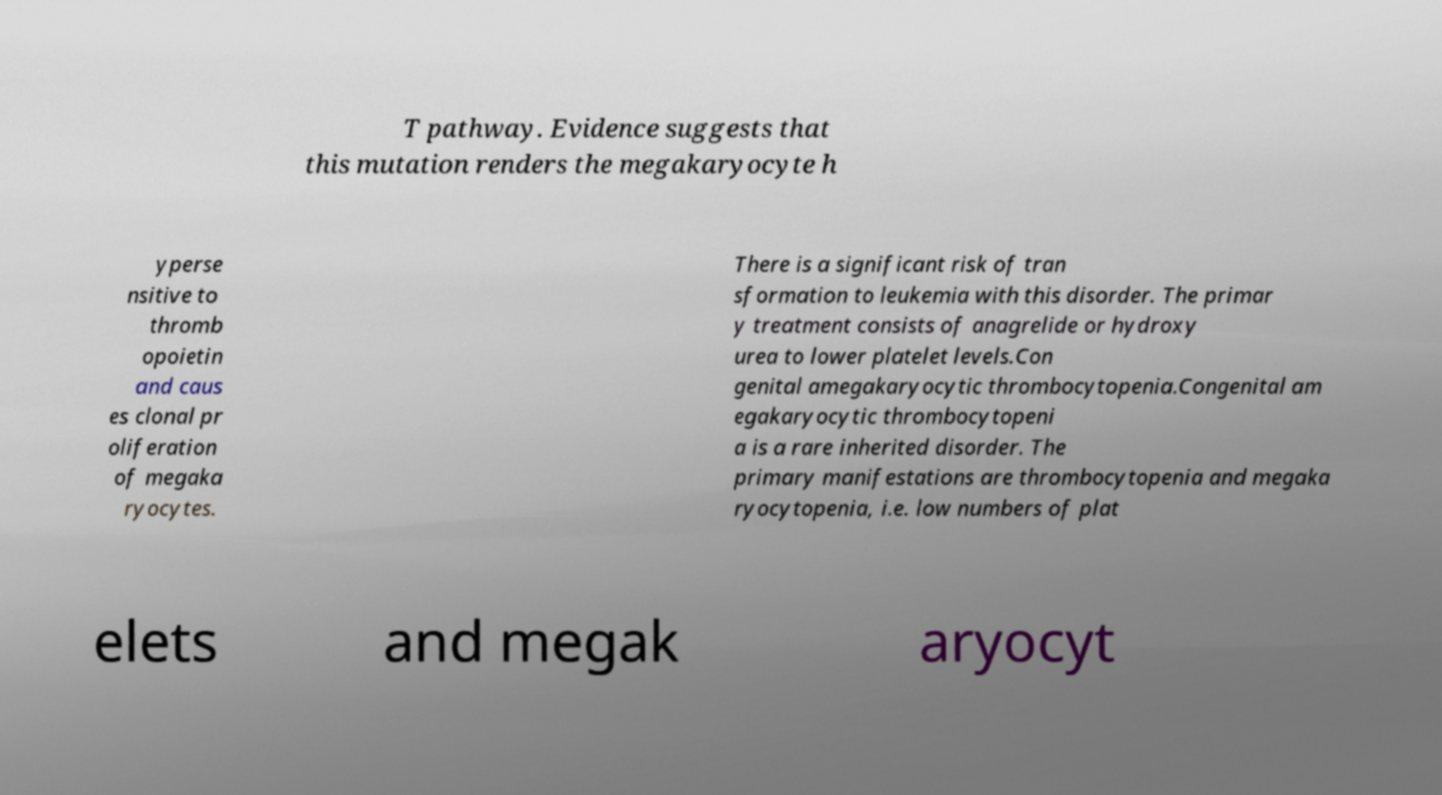I need the written content from this picture converted into text. Can you do that? T pathway. Evidence suggests that this mutation renders the megakaryocyte h yperse nsitive to thromb opoietin and caus es clonal pr oliferation of megaka ryocytes. There is a significant risk of tran sformation to leukemia with this disorder. The primar y treatment consists of anagrelide or hydroxy urea to lower platelet levels.Con genital amegakaryocytic thrombocytopenia.Congenital am egakaryocytic thrombocytopeni a is a rare inherited disorder. The primary manifestations are thrombocytopenia and megaka ryocytopenia, i.e. low numbers of plat elets and megak aryocyt 